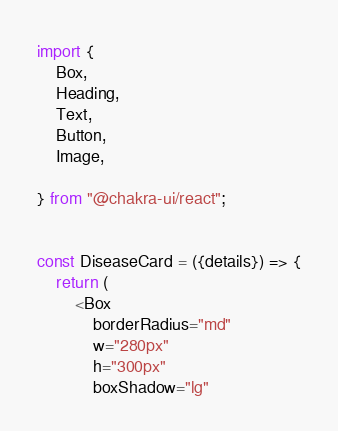Convert code to text. <code><loc_0><loc_0><loc_500><loc_500><_JavaScript_>import {
    Box,
    Heading,
    Text,
    Button,
    Image,
    
} from "@chakra-ui/react";


const DiseaseCard = ({details}) => {
    return (
        <Box
            borderRadius="md"
            w="280px"
            h="300px"
            boxShadow="lg"</code> 